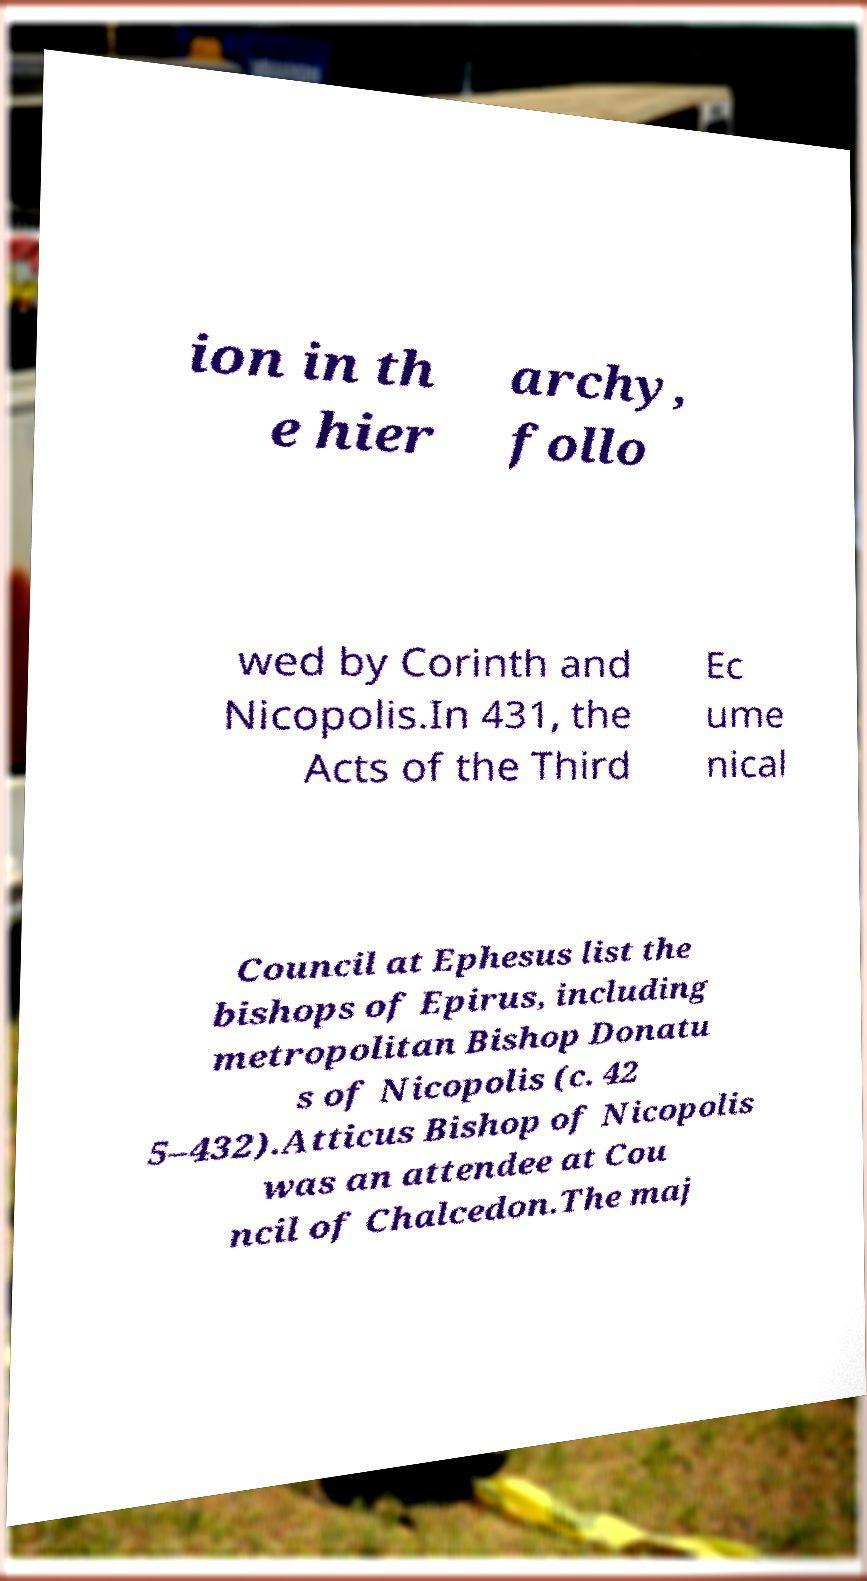Please read and relay the text visible in this image. What does it say? ion in th e hier archy, follo wed by Corinth and Nicopolis.In 431, the Acts of the Third Ec ume nical Council at Ephesus list the bishops of Epirus, including metropolitan Bishop Donatu s of Nicopolis (c. 42 5–432).Atticus Bishop of Nicopolis was an attendee at Cou ncil of Chalcedon.The maj 